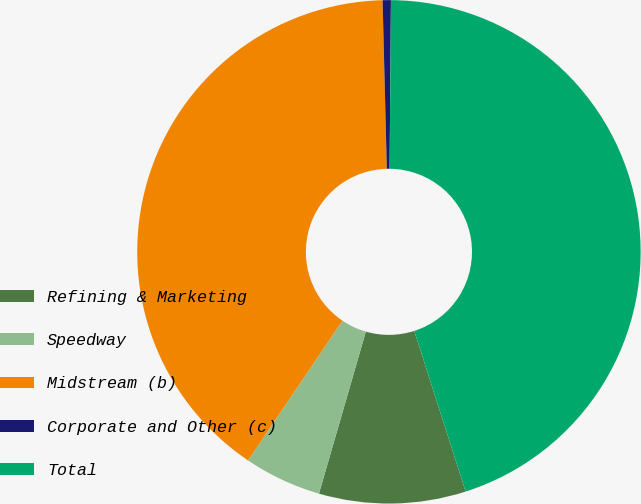Convert chart. <chart><loc_0><loc_0><loc_500><loc_500><pie_chart><fcel>Refining & Marketing<fcel>Speedway<fcel>Midstream (b)<fcel>Corporate and Other (c)<fcel>Total<nl><fcel>9.41%<fcel>4.97%<fcel>40.14%<fcel>0.53%<fcel>44.94%<nl></chart> 